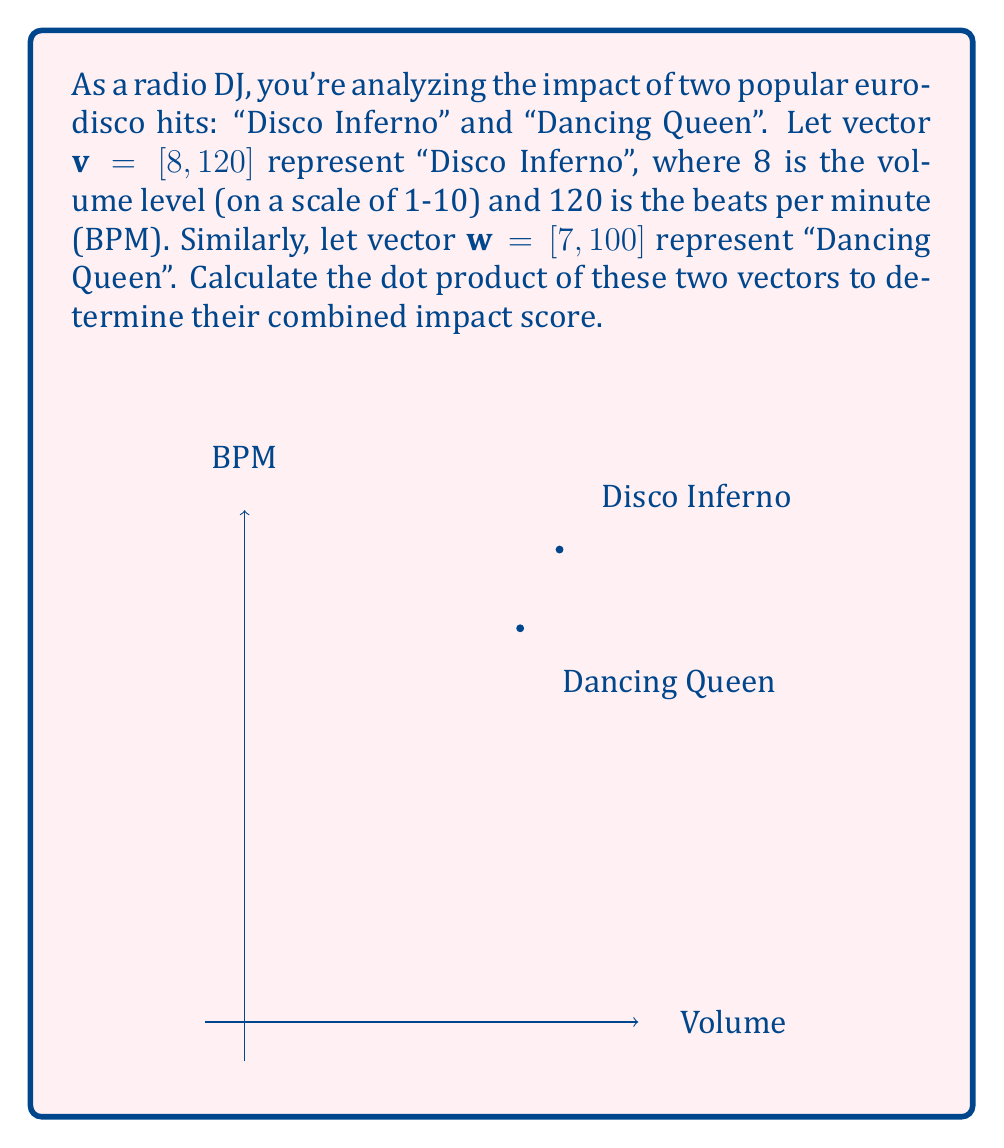Help me with this question. To compute the dot product of two vectors, we multiply corresponding components and sum the results. Let's break it down step-by-step:

1) The formula for the dot product of two vectors $\mathbf{a} = [a_1, a_2]$ and $\mathbf{b} = [b_1, b_2]$ is:

   $$\mathbf{a} \cdot \mathbf{b} = a_1b_1 + a_2b_2$$

2) In our case:
   $\mathbf{v} = [8, 120]$ (Disco Inferno)
   $\mathbf{w} = [7, 100]$ (Dancing Queen)

3) Let's substitute these into our dot product formula:

   $$\mathbf{v} \cdot \mathbf{w} = (8 \times 7) + (120 \times 100)$$

4) Now, let's calculate:
   
   $$\mathbf{v} \cdot \mathbf{w} = 56 + 12000 = 12056$$

This result, 12056, represents the combined impact score of the two songs based on their volume and tempo.
Answer: $12056$ 